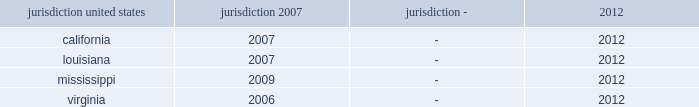As of december 31 , 2012 and 2011 , the estimated value of the company's uncertain tax positions were liabilities of $ 19 million and $ 6 million , respectively .
Assuming sustainment of these positions , the reversal of $ 1 million of the amounts accrued would favorably affect the company's effective federal income tax rate in future periods .
Accrued interest and penalties with respect to unrecognized tax benefits were $ 2 million and $ 3 million as of december 31 , 2012 and 2011 , respectively .
During 2011 , the company recorded a reduction of $ 10 million to its liability for uncertain tax positions relating to tax periods prior to the spin-off for which northrop grumman is the primary obligor .
During 2010 , northrop grumman reached final settlement with the irs and the u .
Congressional joint committee on taxation on the irs examination of northrop grumman's tax returns for the years 2004 through 2006 .
As a result of this settlement , the company recognized tax benefits of $ 8 million as a reduction to the provision for income taxes .
In connection with the settlement , the company also recorded a reduction of $ 10 million to its liability for uncertain tax positions , including previously accrued interest , of $ 2 million .
The table summarizes the tax years that are either currently under examination or remain open under the statute of limitations and subject to examination by the major tax jurisdictions in which the company operates: .
Although the company believes it has adequately provided for all uncertain tax positions , amounts asserted by taxing authorities could be greater than the company's accrued position .
Accordingly , additional provisions on federal and state income tax related matters could be recorded in the future as revised estimates are made or the underlying matters are effectively settled or otherwise resolved .
Conversely , the company could settle positions with the tax authorities for amounts lower than have been accrued .
The company believes it is reasonably possible that during the next 12 months the company's liability for uncertain tax positions may decrease by approximately $ 14 million .
The company recognizes accrued interest and penalties related to uncertain tax positions in income tax expense .
The irs is currently conducting an examination of northrop grumman's consolidated tax returns , of which hii was part , for the years 2007 through 2009 .
Open tax years related to state jurisdictions remain subject to examination .
As of march 31 , 2011 , the date of the spin-off , the company's liability for uncertain tax positions was approximately $ 4 million , net of federal benefit , which related solely to state income tax positions .
Under the terms of the separation agreement , northrop grumman is obligated to reimburse hii for any settlement liabilities paid by hii to any government authority for tax periods prior to the spin-off , which include state income taxes .
Accordingly , the company has recorded a reimbursement receivable of approximately $ 4 million , net of federal benefit , in other assets related to uncertain tax positions for state income taxes as of the date of the spin-off .
Deferred income taxes - deferred income taxes reflect the net tax effects of temporary differences between the carrying amounts of assets and liabilities for financial reporting purposes and income tax purposes .
Such amounts are classified in the consolidated statements of financial position as current or non-current assets or liabilities based upon the classification of the related assets and liabilities. .
How many years of tax examination is the company subject to in virginia? 
Computations: (2012 - 2006)
Answer: 6.0. 